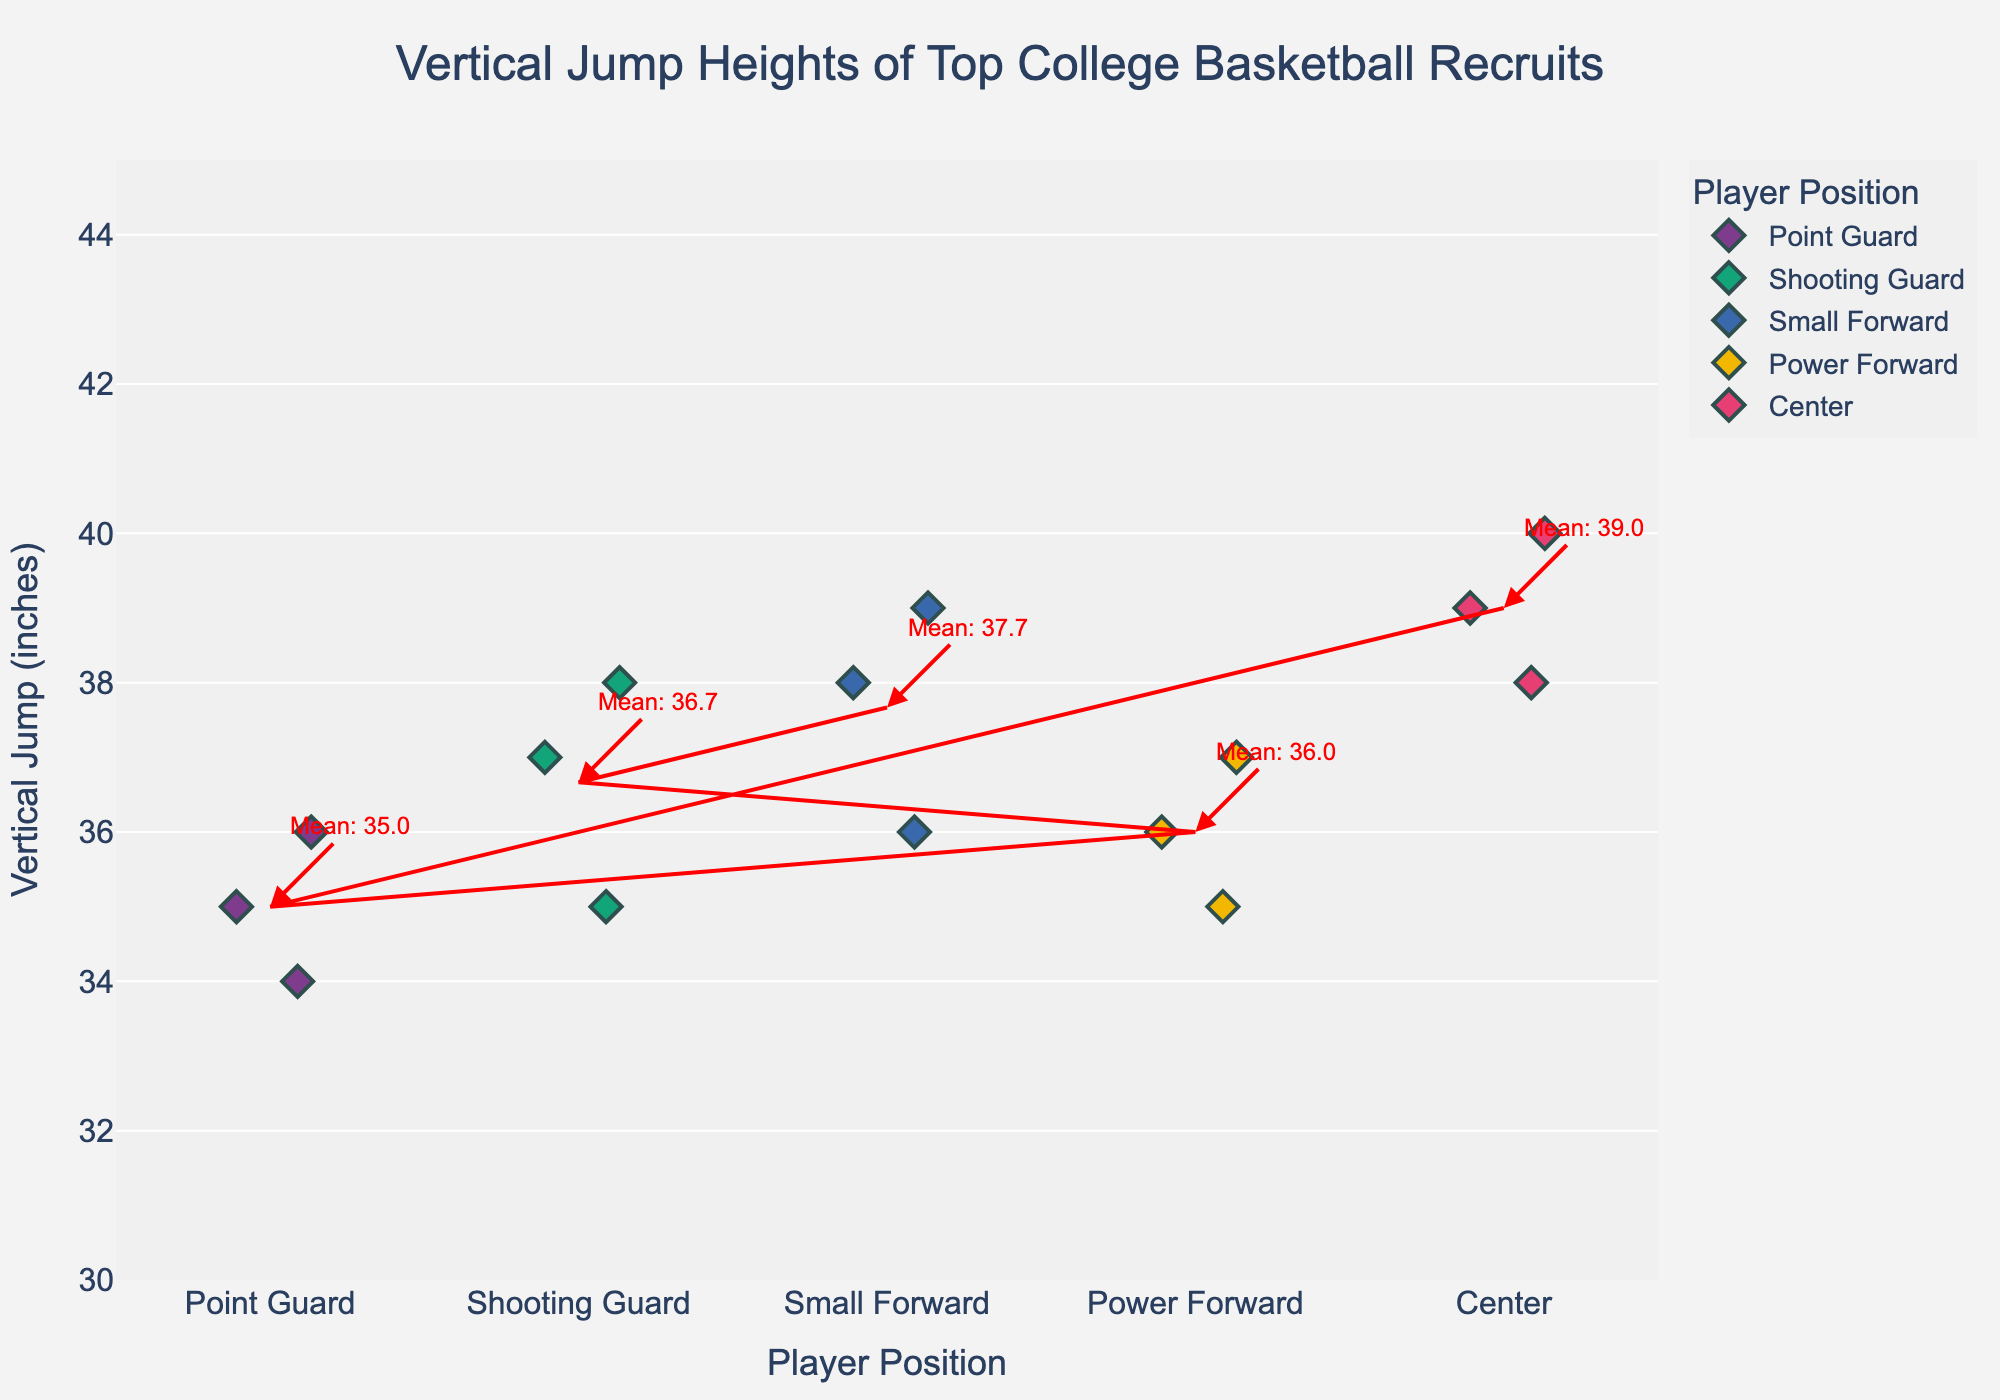What is the title of the plot? The title of the plot is displayed at the top of the figure in larger font size. It summarizes the main content of the figure.
Answer: Vertical Jump Heights of Top College Basketball Recruits Which player has the highest vertical jump among all positions? By examining the y-axis which represents the vertical jump heights and looking for the highest point, we see that the center Evan Mobley has a vertical jump of 40 inches.
Answer: Evan Mobley What is the average vertical jump height for centers? The mean line and annotation provide the average. For the center position, it’s annotated as 39.0.
Answer: 39.0 What player has the lowest vertical jump in the power forward position? By examining the points for the power forward position and identifying the one at the lowest y-axis value, Jalen Johnson has the lowest vertical jump among power forwards at 35 inches.
Answer: Jalen Johnson Are vertical jump heights of point guards generally higher or lower than those of centers? By comparing the general distribution of the points for point guards and centers, centers have generally higher vertical jumps with their mean being higher than that of point guards.
Answer: Lower Which position has the narrowest spread in vertical jump heights? By looking at the spread of the points (how close together they are on the y-axis), point guards have the narrowest spread with jumps ranging from 34 to 36 inches.
Answer: Point Guard How many players have a vertical jump of 38 inches? By counting all points at the 38 inches y-axis value, there are four such points: James Bouknight, Jonathan Kuminga, Day'Ron Sharpe, and Kai Jones.
Answer: Four Which player has the highest vertical jump among the shooting guards? By locating the highest point in the shooting guard position category, James Bouknight has the highest vertical jump at 38 inches.
Answer: James Bouknight Is there any position where no player's vertical jump is above 37 inches? By examining each position category, all categories have at least one player above 37 inches. Thus, there is no such position.
Answer: No 